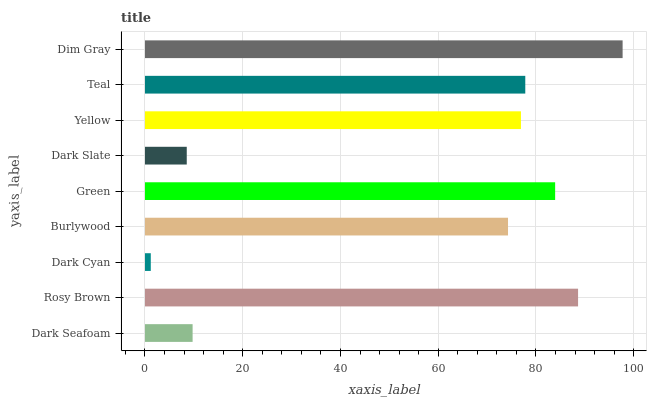Is Dark Cyan the minimum?
Answer yes or no. Yes. Is Dim Gray the maximum?
Answer yes or no. Yes. Is Rosy Brown the minimum?
Answer yes or no. No. Is Rosy Brown the maximum?
Answer yes or no. No. Is Rosy Brown greater than Dark Seafoam?
Answer yes or no. Yes. Is Dark Seafoam less than Rosy Brown?
Answer yes or no. Yes. Is Dark Seafoam greater than Rosy Brown?
Answer yes or no. No. Is Rosy Brown less than Dark Seafoam?
Answer yes or no. No. Is Yellow the high median?
Answer yes or no. Yes. Is Yellow the low median?
Answer yes or no. Yes. Is Teal the high median?
Answer yes or no. No. Is Dark Seafoam the low median?
Answer yes or no. No. 